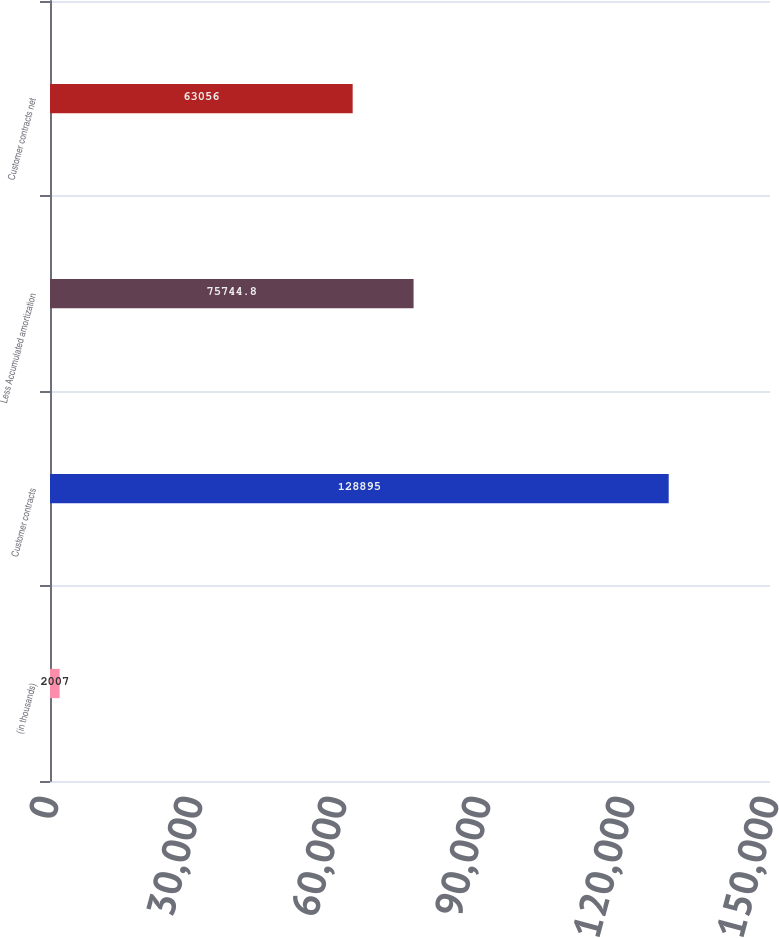Convert chart to OTSL. <chart><loc_0><loc_0><loc_500><loc_500><bar_chart><fcel>(in thousands)<fcel>Customer contracts<fcel>Less Accumulated amortization<fcel>Customer contracts net<nl><fcel>2007<fcel>128895<fcel>75744.8<fcel>63056<nl></chart> 